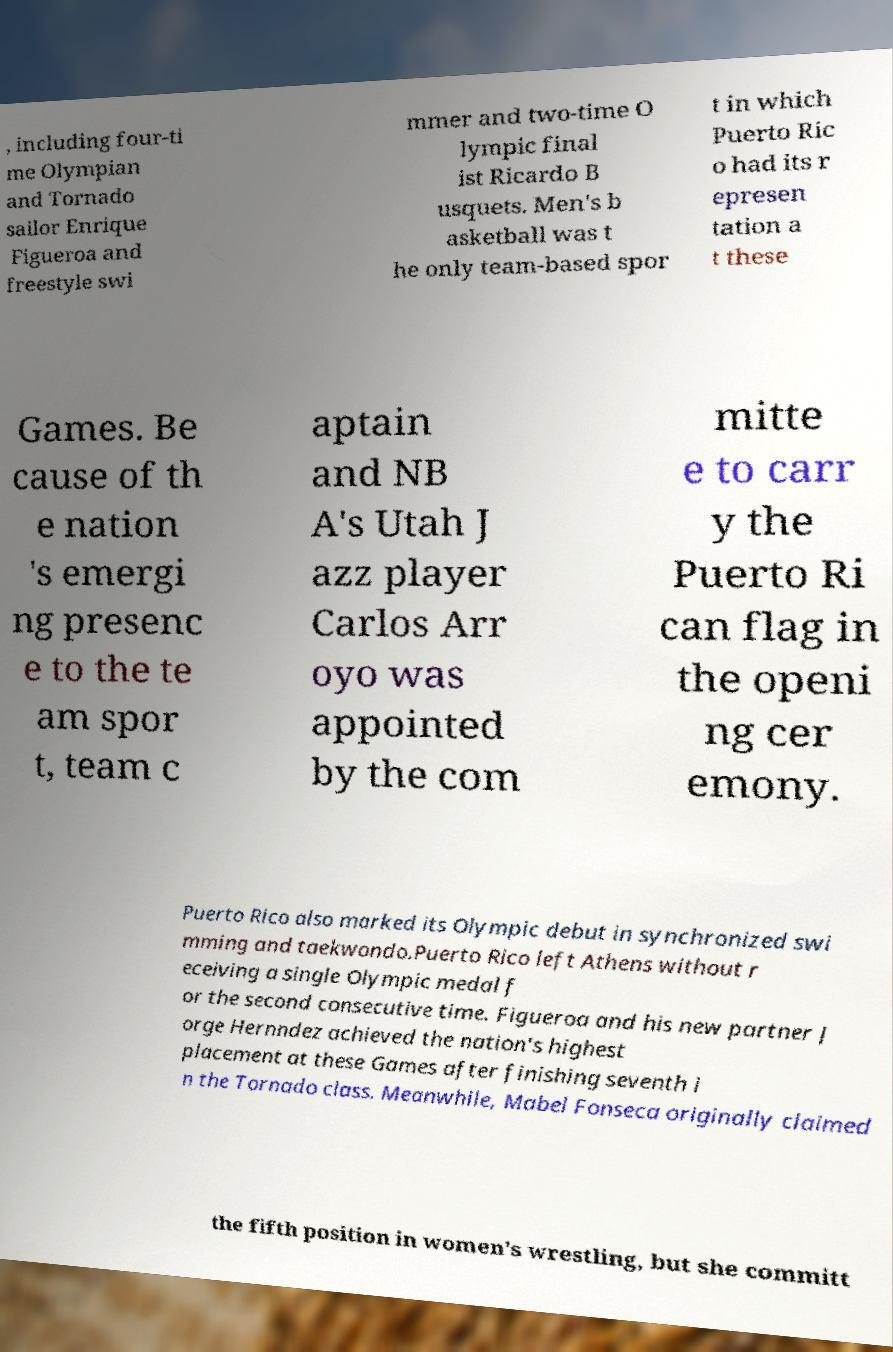Could you assist in decoding the text presented in this image and type it out clearly? , including four-ti me Olympian and Tornado sailor Enrique Figueroa and freestyle swi mmer and two-time O lympic final ist Ricardo B usquets. Men's b asketball was t he only team-based spor t in which Puerto Ric o had its r epresen tation a t these Games. Be cause of th e nation 's emergi ng presenc e to the te am spor t, team c aptain and NB A's Utah J azz player Carlos Arr oyo was appointed by the com mitte e to carr y the Puerto Ri can flag in the openi ng cer emony. Puerto Rico also marked its Olympic debut in synchronized swi mming and taekwondo.Puerto Rico left Athens without r eceiving a single Olympic medal f or the second consecutive time. Figueroa and his new partner J orge Hernndez achieved the nation's highest placement at these Games after finishing seventh i n the Tornado class. Meanwhile, Mabel Fonseca originally claimed the fifth position in women's wrestling, but she committ 